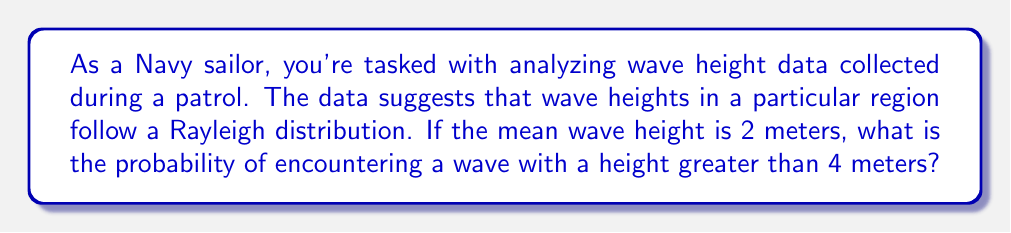Teach me how to tackle this problem. Let's approach this step-by-step:

1) The Rayleigh distribution is often used to model wave heights in oceanography. Its probability density function (PDF) is given by:

   $$f(x) = \frac{x}{\sigma^2} e^{-x^2/(2\sigma^2)}$$

   where $\sigma$ is the scale parameter.

2) For a Rayleigh distribution, the mean $\mu$ is related to $\sigma$ by:

   $$\mu = \sigma \sqrt{\frac{\pi}{2}}$$

3) We're given that the mean wave height $\mu = 2$ meters. Let's solve for $\sigma$:

   $$2 = \sigma \sqrt{\frac{\pi}{2}}$$
   $$\sigma = \frac{2}{\sqrt{\frac{\pi}{2}}} \approx 1.5958$$

4) The cumulative distribution function (CDF) of the Rayleigh distribution is:

   $$F(x) = 1 - e^{-x^2/(2\sigma^2)}$$

5) We want the probability of a wave height greater than 4 meters, which is the complement of the CDF at x = 4:

   $$P(X > 4) = 1 - F(4) = e^{-4^2/(2\sigma^2)}$$

6) Substituting our value for $\sigma$:

   $$P(X > 4) = e^{-4^2/(2(1.5958)^2)} \approx 0.0432$$

7) Converting to a percentage:

   $$0.0432 \times 100\% = 4.32\%$$
Answer: 4.32% 